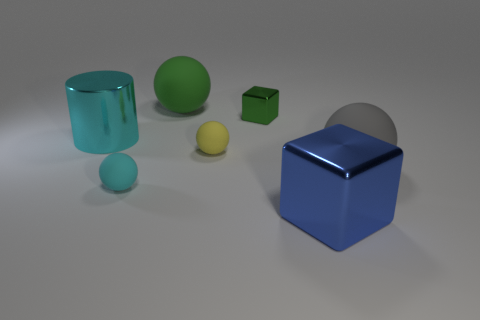What number of spheres are either large matte things or cyan metallic things?
Your response must be concise. 2. There is a big sphere that is made of the same material as the gray object; what color is it?
Give a very brief answer. Green. Are the cyan cylinder and the large object on the right side of the blue object made of the same material?
Ensure brevity in your answer.  No. What number of things are gray balls or large green things?
Make the answer very short. 2. What is the material of the big ball that is the same color as the small block?
Offer a very short reply. Rubber. Is there another green metallic object of the same shape as the tiny metallic object?
Keep it short and to the point. No. How many cyan matte objects are left of the blue shiny block?
Provide a short and direct response. 1. What material is the cyan thing that is behind the small matte object that is on the right side of the tiny cyan matte thing?
Make the answer very short. Metal. What is the material of the ball that is the same size as the gray matte object?
Give a very brief answer. Rubber. Are there any green rubber things that have the same size as the gray thing?
Offer a very short reply. Yes. 